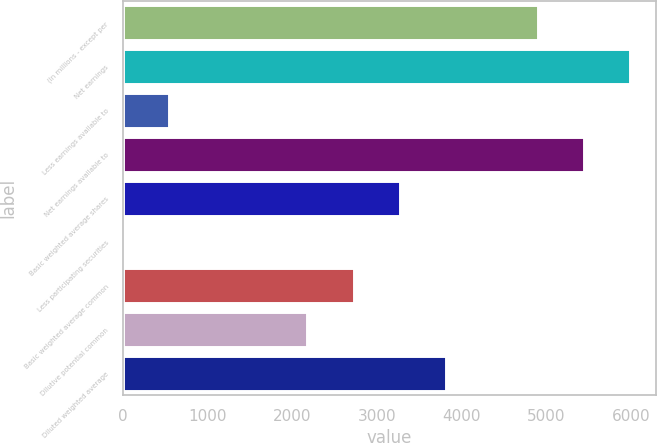Convert chart. <chart><loc_0><loc_0><loc_500><loc_500><bar_chart><fcel>(In millions - except per<fcel>Net earnings<fcel>Less earnings available to<fcel>Net earnings available to<fcel>Basic weighted average shares<fcel>Less participating securities<fcel>Basic weighted average common<fcel>Dilutive potential common<fcel>Diluted weighted average<nl><fcel>4901.53<fcel>5990.47<fcel>545.77<fcel>5446<fcel>3268.12<fcel>1.3<fcel>2723.65<fcel>2179.18<fcel>3812.59<nl></chart> 